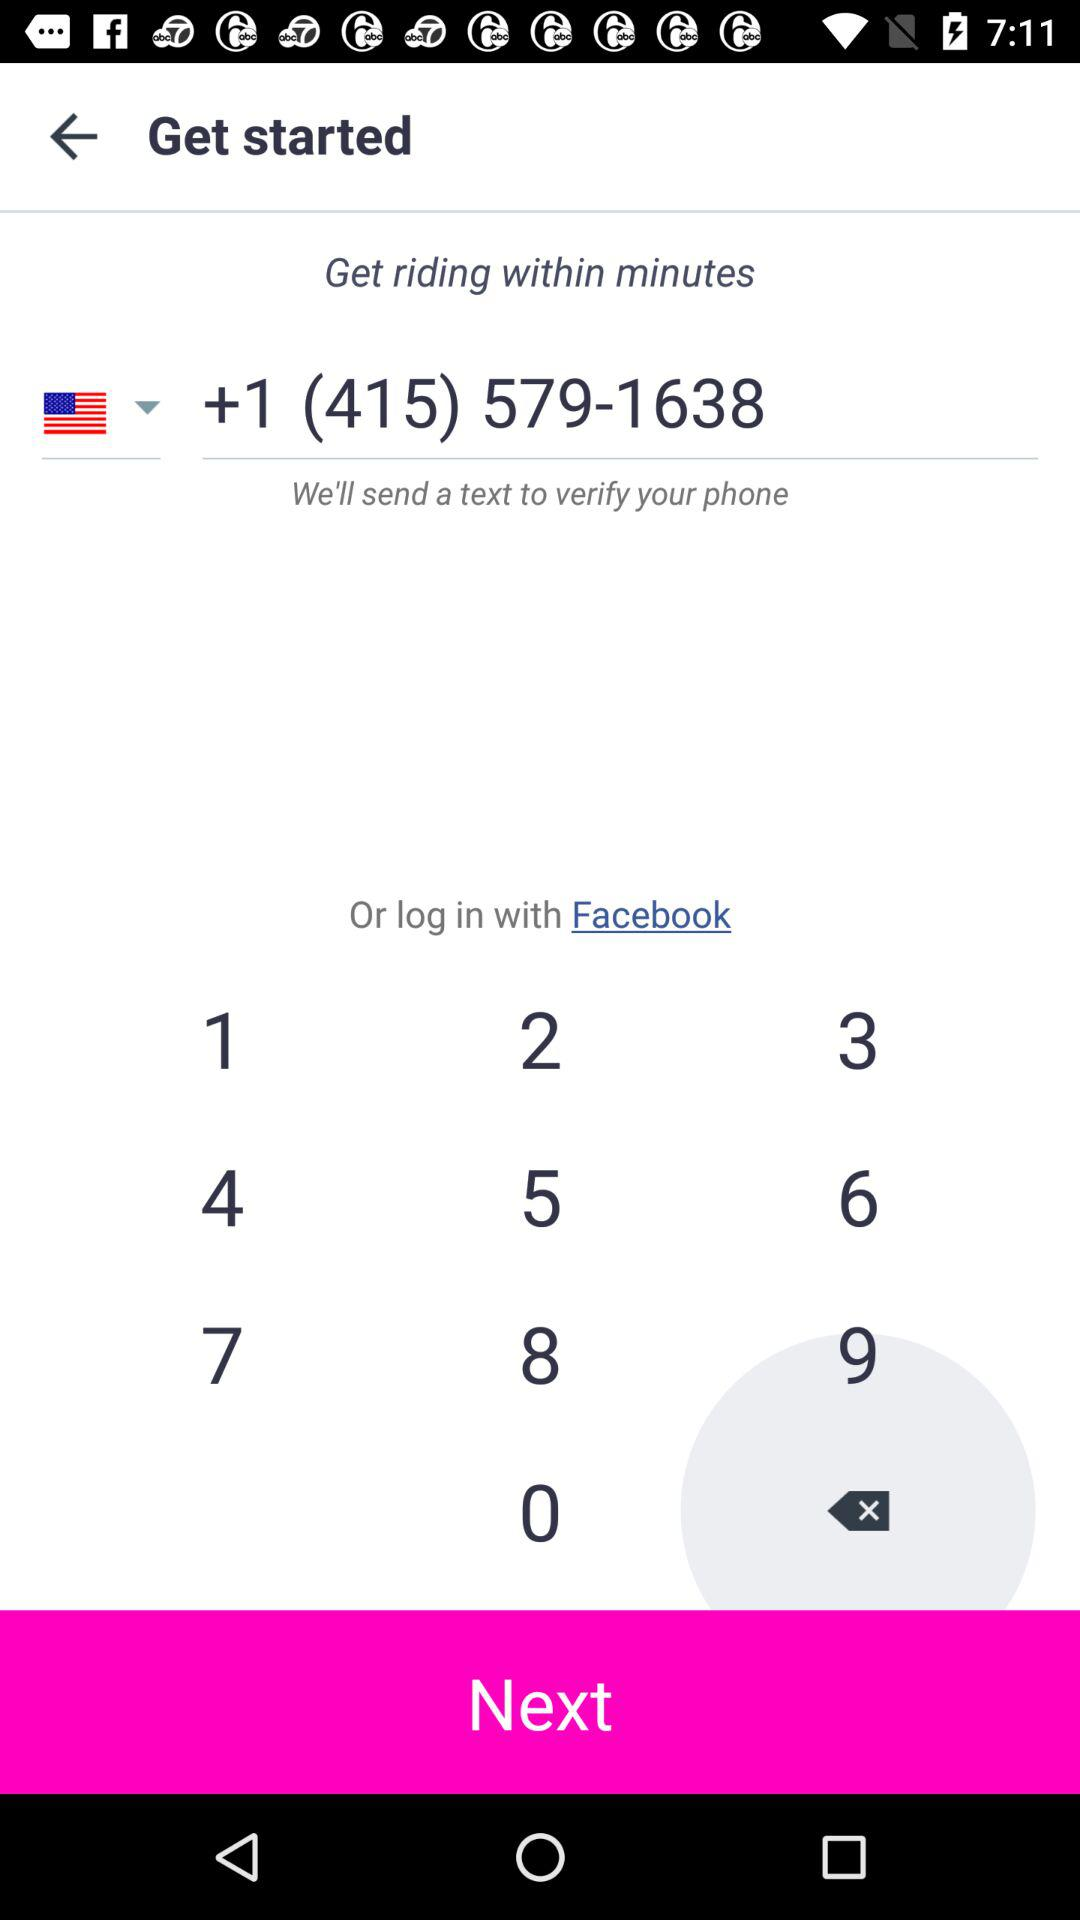What is the name of the application?
When the provided information is insufficient, respond with <no answer>. <no answer> 